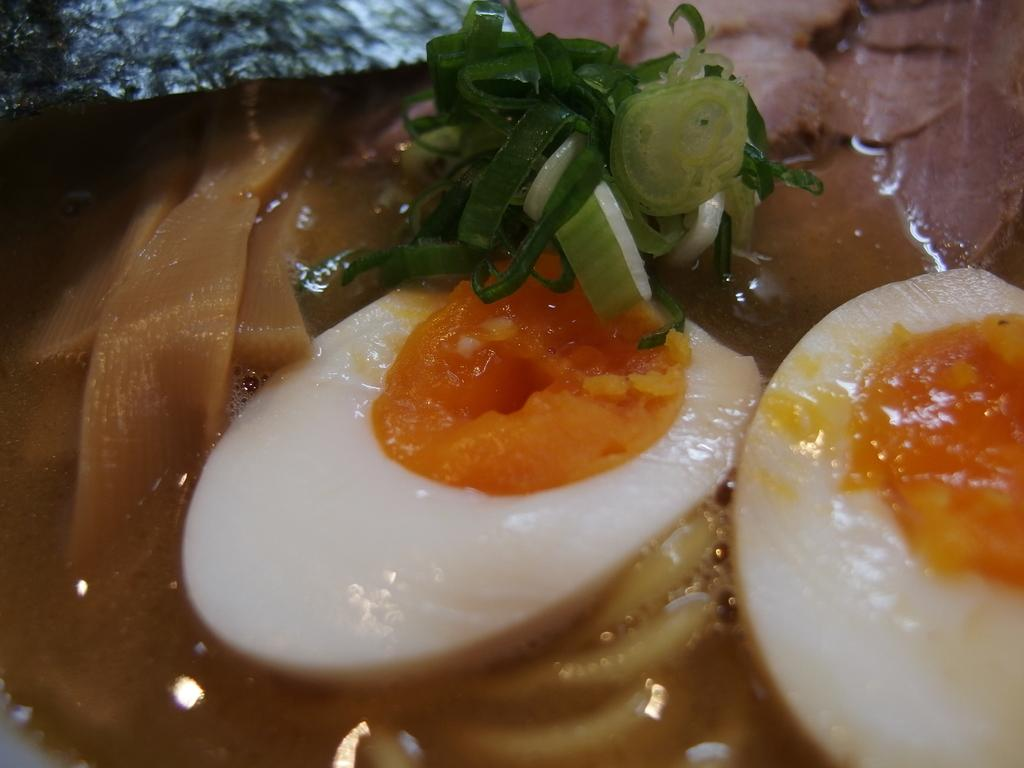What is the focus of the image? The image is zoomed in, with a boiled egg in the center of the image. What else can be seen in the image besides the boiled egg? There are food items visible in the image. How many legs does the insect have in the image? There is no insect present in the image. 